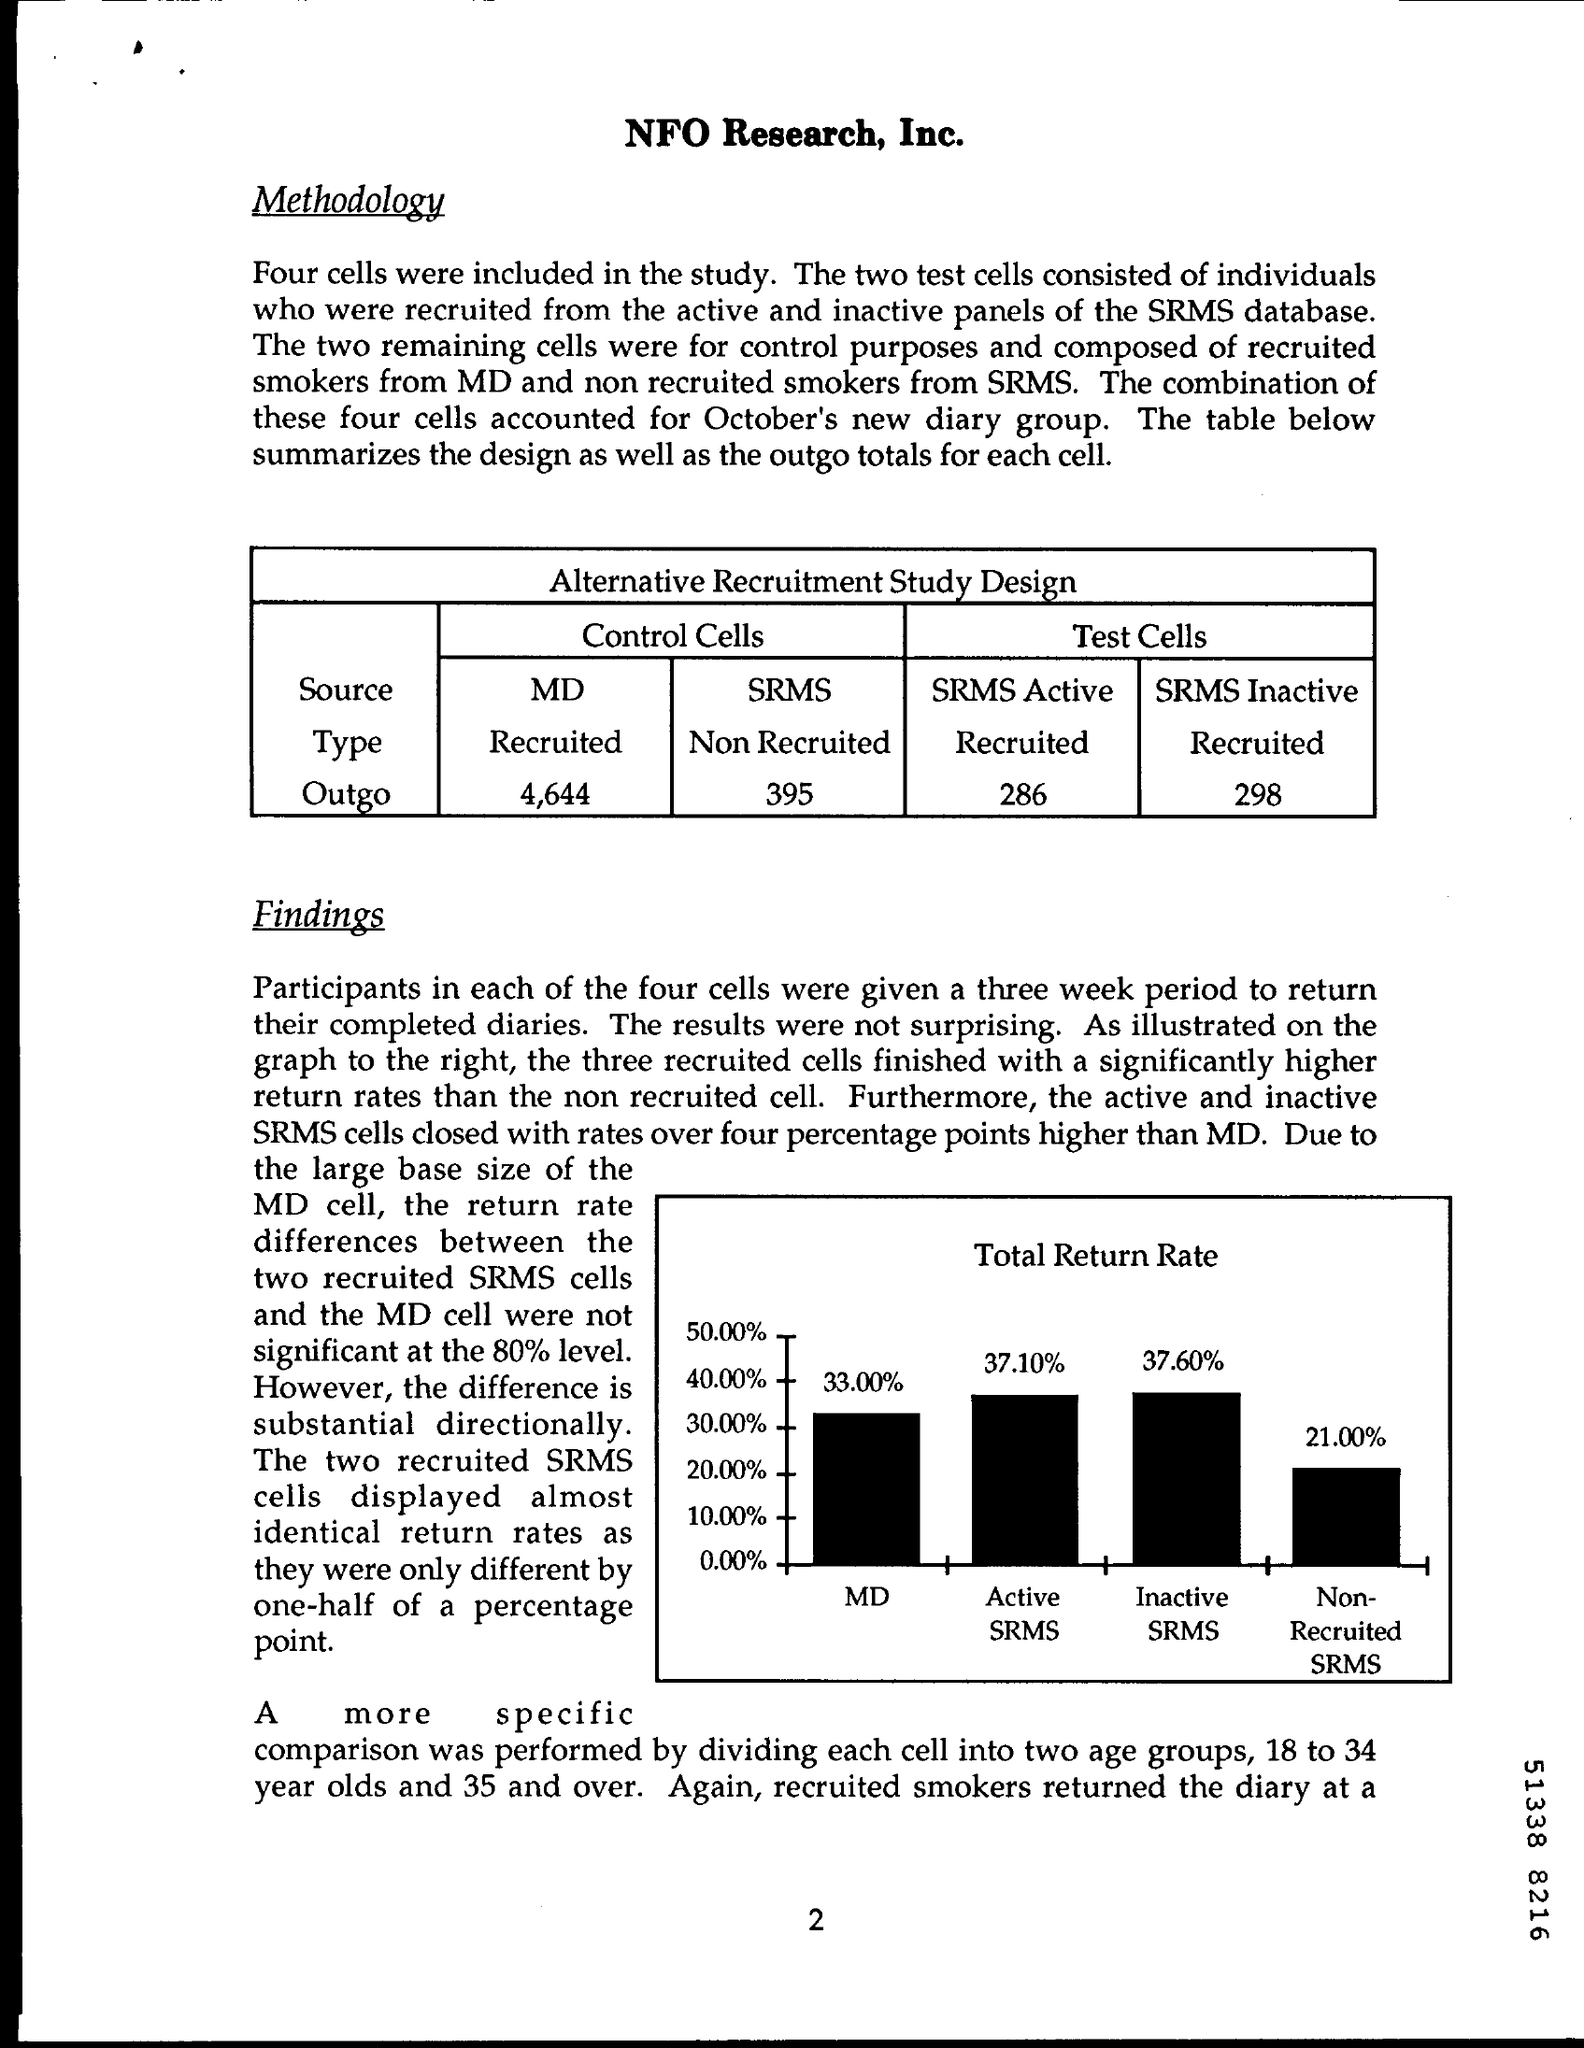Point out several critical features in this image. The value of outgo in SRMS Active in the test cells is 286. SRMS cells in control cells are of a non-recruited type. The type of SRMS inactive in the test cells is "Recruited". The outgo of MD cells in the control cells is 4,644. 